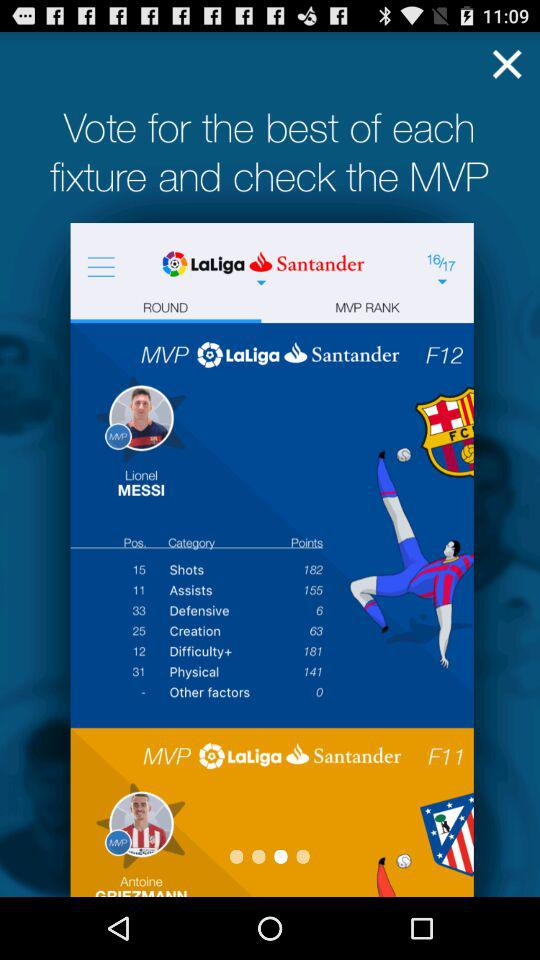What is the count of points for shots? The count of points for shots is 182. 